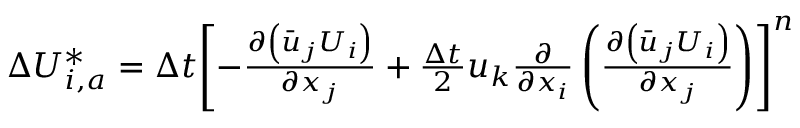Convert formula to latex. <formula><loc_0><loc_0><loc_500><loc_500>\begin{array} { r } { \Delta U _ { i , a } ^ { * } = \Delta t { { \left [ - \frac { \partial \left ( { { { \bar { u } } } _ { j } } { { U } _ { i } } \right ) } { \partial { { x } _ { j } } } + \frac { \Delta t } { 2 } { { u } _ { k } } \frac { \partial } { \partial { { x } _ { i } } } \left ( \frac { \partial \left ( { { { \bar { u } } } _ { j } } { { U } _ { i } } \right ) } { \partial { { x } _ { j } } } \right ) \right ] } ^ { n } } } \end{array}</formula> 